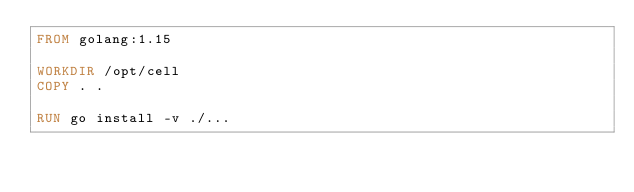Convert code to text. <code><loc_0><loc_0><loc_500><loc_500><_Dockerfile_>FROM golang:1.15

WORKDIR /opt/cell
COPY . .

RUN go install -v ./...
</code> 